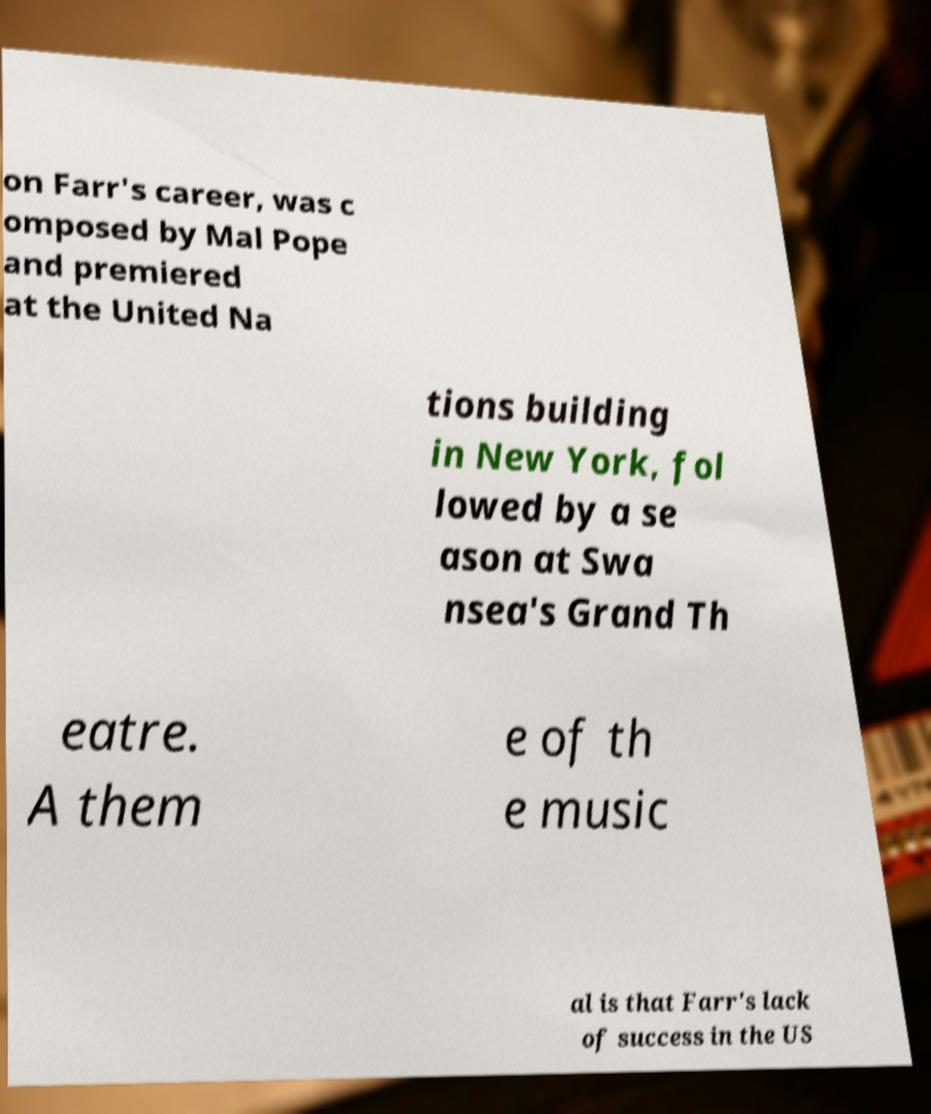Could you extract and type out the text from this image? on Farr's career, was c omposed by Mal Pope and premiered at the United Na tions building in New York, fol lowed by a se ason at Swa nsea's Grand Th eatre. A them e of th e music al is that Farr's lack of success in the US 